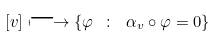Convert formula to latex. <formula><loc_0><loc_0><loc_500><loc_500>[ v ] \longmapsto \{ \varphi \ \colon \ \alpha _ { v } \circ \varphi = 0 \}</formula> 